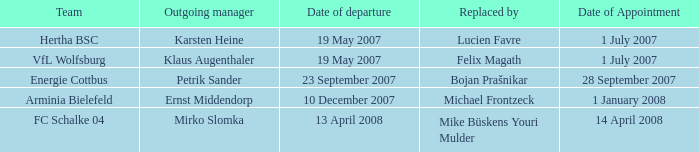When was the appointment date for the manager replaced by Lucien Favre? 1 July 2007. 